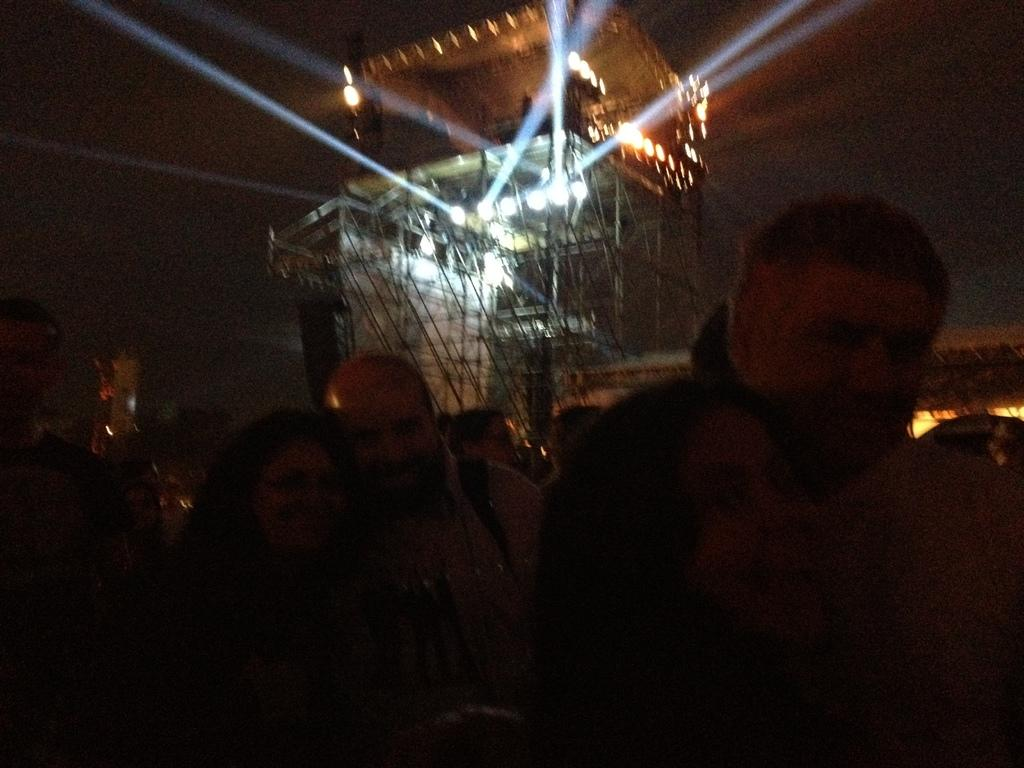How many people are in the image? There is a group of persons in the image, but the exact number cannot be determined from the provided facts. What can be seen in the background of the image? There are lights and a tower in the background of the image. What type of shoe is hanging from the tower in the image? There is no shoe present in the image, and therefore no such object can be observed hanging from the tower. 